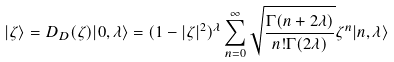Convert formula to latex. <formula><loc_0><loc_0><loc_500><loc_500>| \zeta \rangle = D _ { D } ( \zeta ) | 0 , \lambda \rangle = ( 1 - | \zeta | ^ { 2 } ) ^ { \lambda } \sum _ { n = 0 } ^ { \infty } \sqrt { \frac { \Gamma ( n + 2 \lambda ) } { n ! \Gamma ( 2 \lambda ) } } \zeta ^ { n } | n , \lambda \rangle</formula> 